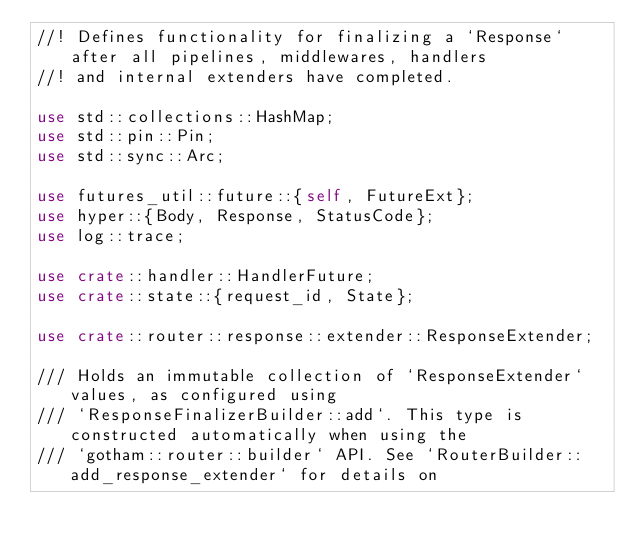Convert code to text. <code><loc_0><loc_0><loc_500><loc_500><_Rust_>//! Defines functionality for finalizing a `Response` after all pipelines, middlewares, handlers
//! and internal extenders have completed.

use std::collections::HashMap;
use std::pin::Pin;
use std::sync::Arc;

use futures_util::future::{self, FutureExt};
use hyper::{Body, Response, StatusCode};
use log::trace;

use crate::handler::HandlerFuture;
use crate::state::{request_id, State};

use crate::router::response::extender::ResponseExtender;

/// Holds an immutable collection of `ResponseExtender` values, as configured using
/// `ResponseFinalizerBuilder::add`. This type is constructed automatically when using the
/// `gotham::router::builder` API. See `RouterBuilder::add_response_extender` for details on</code> 